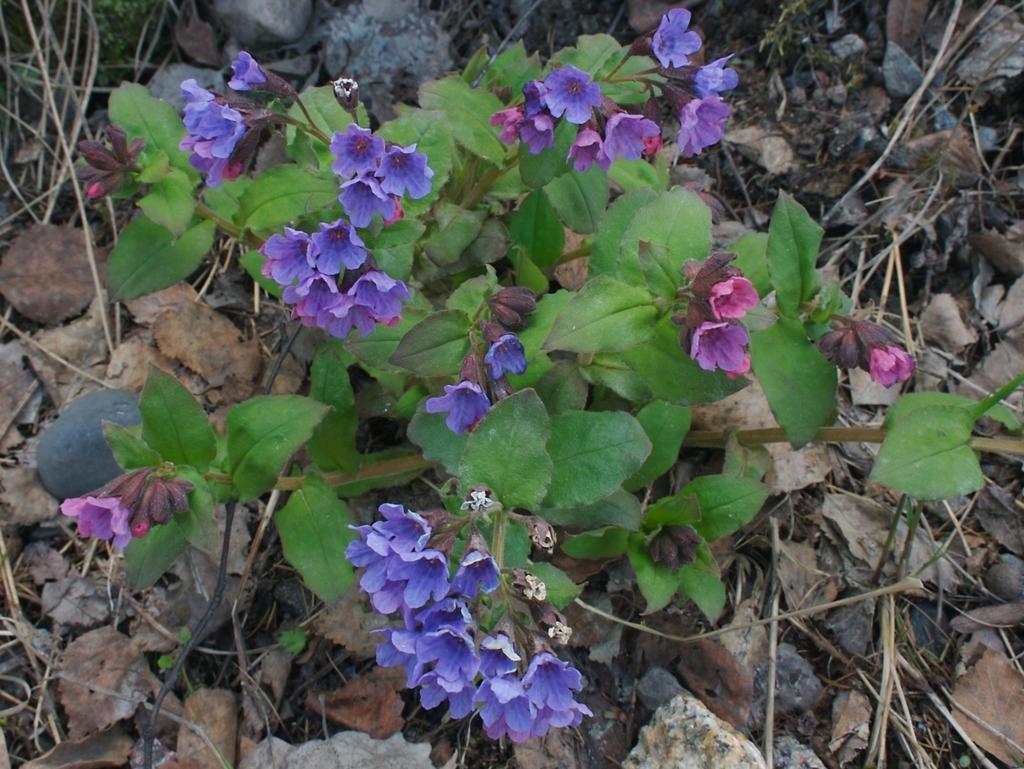In one or two sentences, can you explain what this image depicts? In this picture we can see a plant and flowers in the front, at the bottom there are some leaves. 